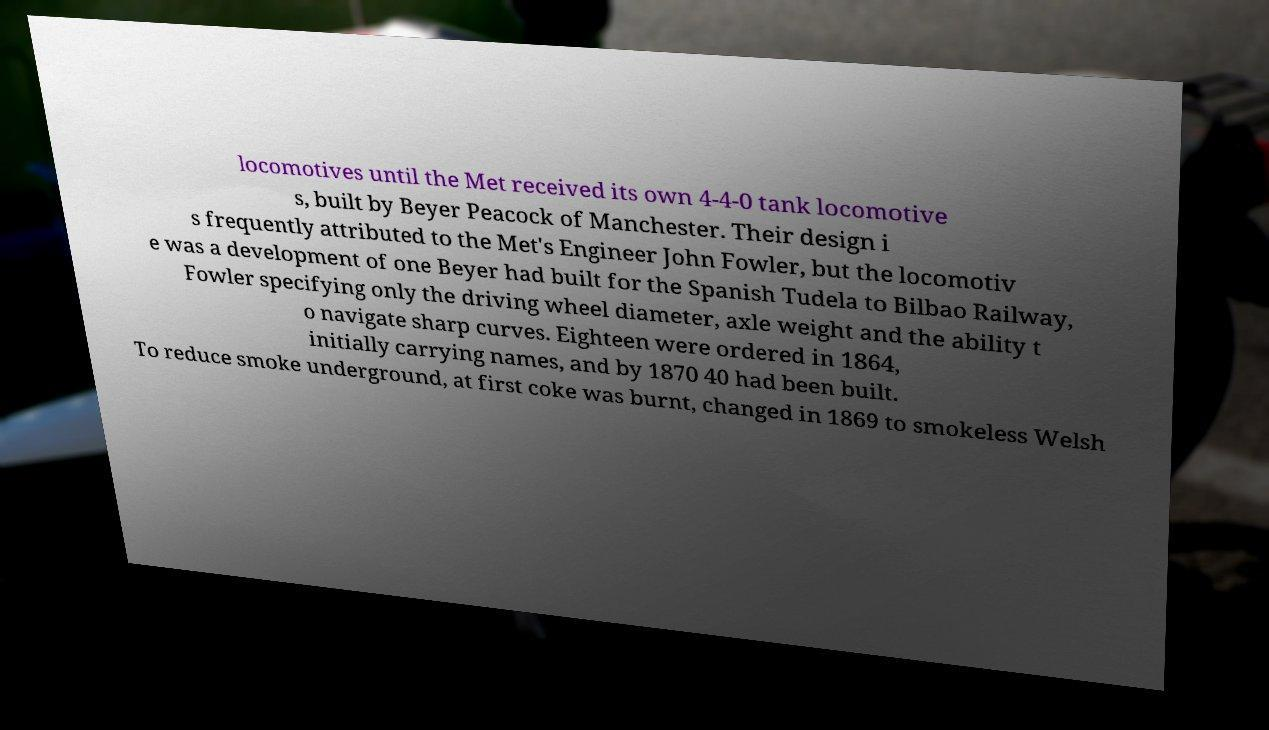I need the written content from this picture converted into text. Can you do that? locomotives until the Met received its own 4-4-0 tank locomotive s, built by Beyer Peacock of Manchester. Their design i s frequently attributed to the Met's Engineer John Fowler, but the locomotiv e was a development of one Beyer had built for the Spanish Tudela to Bilbao Railway, Fowler specifying only the driving wheel diameter, axle weight and the ability t o navigate sharp curves. Eighteen were ordered in 1864, initially carrying names, and by 1870 40 had been built. To reduce smoke underground, at first coke was burnt, changed in 1869 to smokeless Welsh 